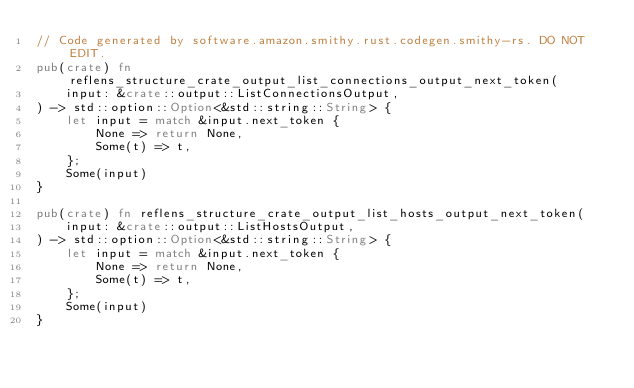<code> <loc_0><loc_0><loc_500><loc_500><_Rust_>// Code generated by software.amazon.smithy.rust.codegen.smithy-rs. DO NOT EDIT.
pub(crate) fn reflens_structure_crate_output_list_connections_output_next_token(
    input: &crate::output::ListConnectionsOutput,
) -> std::option::Option<&std::string::String> {
    let input = match &input.next_token {
        None => return None,
        Some(t) => t,
    };
    Some(input)
}

pub(crate) fn reflens_structure_crate_output_list_hosts_output_next_token(
    input: &crate::output::ListHostsOutput,
) -> std::option::Option<&std::string::String> {
    let input = match &input.next_token {
        None => return None,
        Some(t) => t,
    };
    Some(input)
}
</code> 